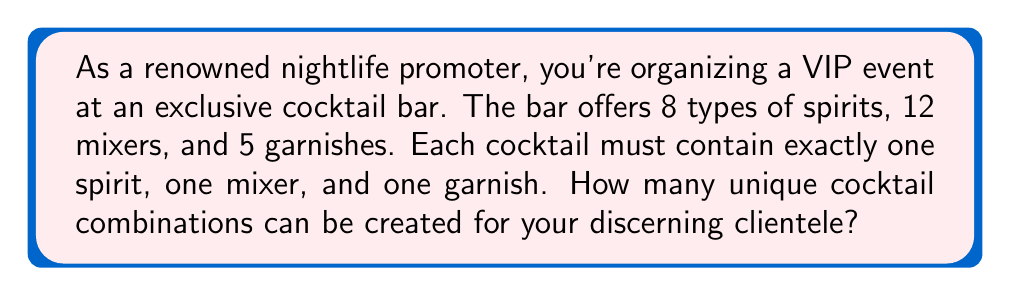Show me your answer to this math problem. Let's approach this step-by-step using the multiplication principle of counting:

1) For each cocktail, we need to choose:
   - One spirit out of 8 options
   - One mixer out of 12 options
   - One garnish out of 5 options

2) These choices are independent of each other. For each choice of spirit, we can choose any of the mixers, and for each spirit-mixer combination, we can choose any of the garnishes.

3) Therefore, we can multiply the number of options for each component:

   $$ \text{Total combinations} = \text{Spirit options} \times \text{Mixer options} \times \text{Garnish options} $$

4) Substituting the values:

   $$ \text{Total combinations} = 8 \times 12 \times 5 $$

5) Calculating:

   $$ \text{Total combinations} = 480 $$

Thus, there are 480 unique cocktail combinations that can be created, offering a wide variety of options for your VIP guests.
Answer: 480 